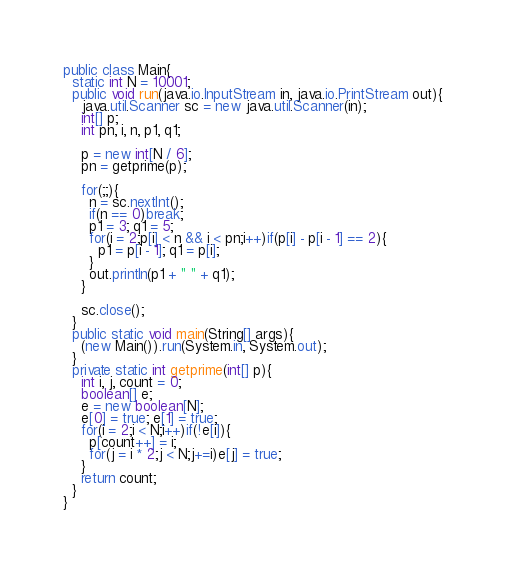Convert code to text. <code><loc_0><loc_0><loc_500><loc_500><_Java_>public class Main{
  static int N = 10001;
  public void run(java.io.InputStream in, java.io.PrintStream out){
    java.util.Scanner sc = new java.util.Scanner(in);
    int[] p;
    int pn, i, n, p1, q1;

    p = new int[N / 6];
    pn = getprime(p);

    for(;;){
      n = sc.nextInt();
      if(n == 0)break;
      p1 = 3; q1 = 5;
      for(i = 2;p[i] < n && i < pn;i++)if(p[i] - p[i - 1] == 2){
        p1 = p[i - 1]; q1 = p[i];
      }
      out.println(p1 + " " + q1);
    }

    sc.close();
  }
  public static void main(String[] args){
    (new Main()).run(System.in, System.out);
  }
  private static int getprime(int[] p){
    int i, j, count = 0;
    boolean[] e;
    e = new boolean[N];
    e[0] = true; e[1] = true;
    for(i = 2;i < N;i++)if(!e[i]){
      p[count++] = i;
      for(j = i * 2;j < N;j+=i)e[j] = true;
    }
    return count;
  }
}</code> 